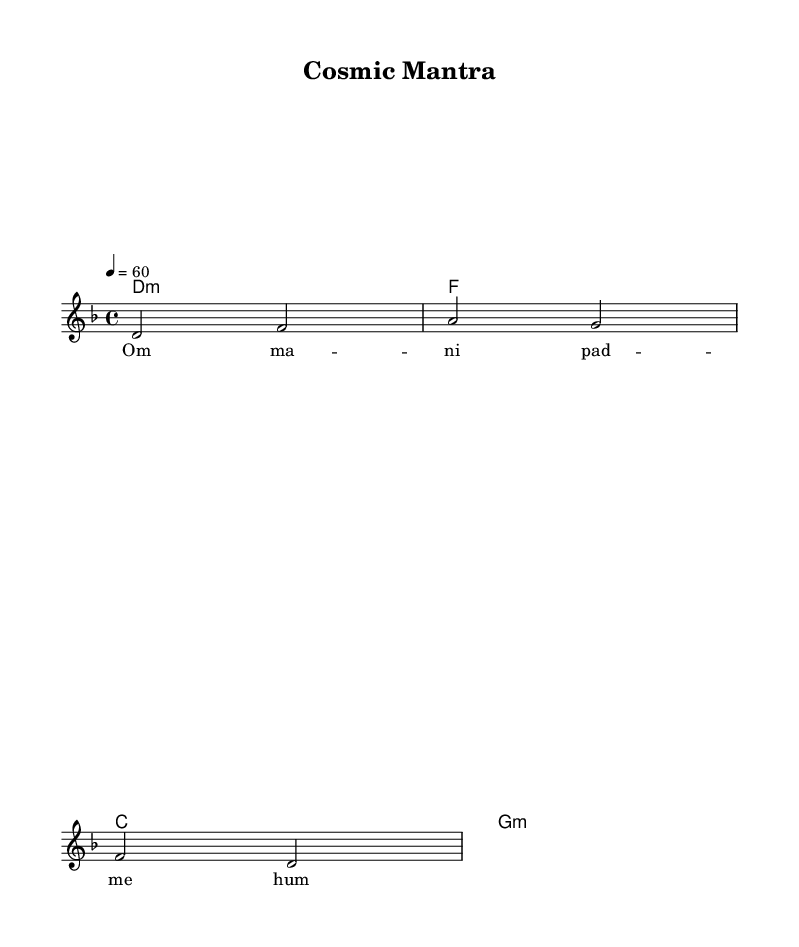What is the key signature of this music? The key signature is indicated in the global section as D minor, which contains one flat (B flat).
Answer: D minor What is the time signature of this piece? The time signature is also found in the global section and is notated as 4/4, meaning there are four beats in each measure.
Answer: 4/4 What is the tempo marking for the music? The tempo marking appears in the global section, denoting a speed of quarter note equals 60 beats per minute, which sets a slow, meditative pace.
Answer: 60 How many measures are in the melody? By analyzing the voice part and counting the distinct groupings of notes, there are a total of four measures noted in the melody section.
Answer: 4 What is the lyrical text of this chant? The lyrics are provided in the verse section and say "Om mani padme hum", which is a traditional meditative chant.
Answer: Om mani padme hum What type of chords are used in the harmonies? The harmony section contains a mix of minor chords, as indicated by the notation d1:m (D minor), f1 (F major), c1 (C major), and g1:m (G minor).
Answer: Minor chords How does the melody relate to the lyrics? The melody is set to the lyrics, with each note aligning with corresponding syllables from "Om mani padme hum", creating a vocal chant that follows the melodic line.
Answer: Vocal chant 